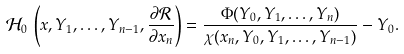Convert formula to latex. <formula><loc_0><loc_0><loc_500><loc_500>\mathcal { H } _ { 0 } \, \left ( x , Y _ { 1 } , \dots , Y _ { n - 1 } , \frac { \partial \mathcal { R } } { \partial { x } _ { n } } \right ) = \frac { \Phi ( Y _ { 0 } , Y _ { 1 } , \dots , Y _ { n } ) } { \chi ( x _ { n } , Y _ { 0 } , Y _ { 1 } , \dots , Y _ { n - 1 } ) } - Y _ { 0 } .</formula> 